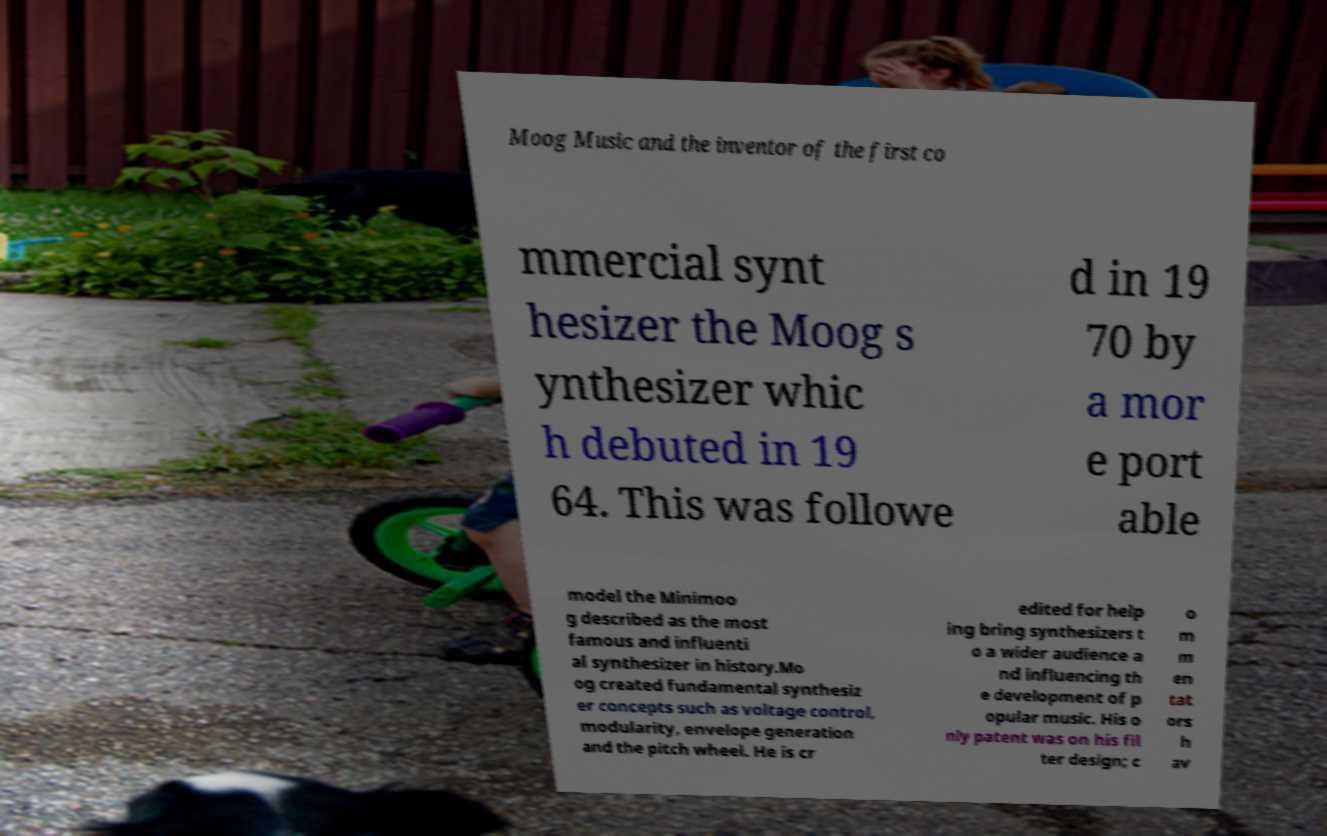What messages or text are displayed in this image? I need them in a readable, typed format. Moog Music and the inventor of the first co mmercial synt hesizer the Moog s ynthesizer whic h debuted in 19 64. This was followe d in 19 70 by a mor e port able model the Minimoo g described as the most famous and influenti al synthesizer in history.Mo og created fundamental synthesiz er concepts such as voltage control, modularity, envelope generation and the pitch wheel. He is cr edited for help ing bring synthesizers t o a wider audience a nd influencing th e development of p opular music. His o nly patent was on his fil ter design; c o m m en tat ors h av 